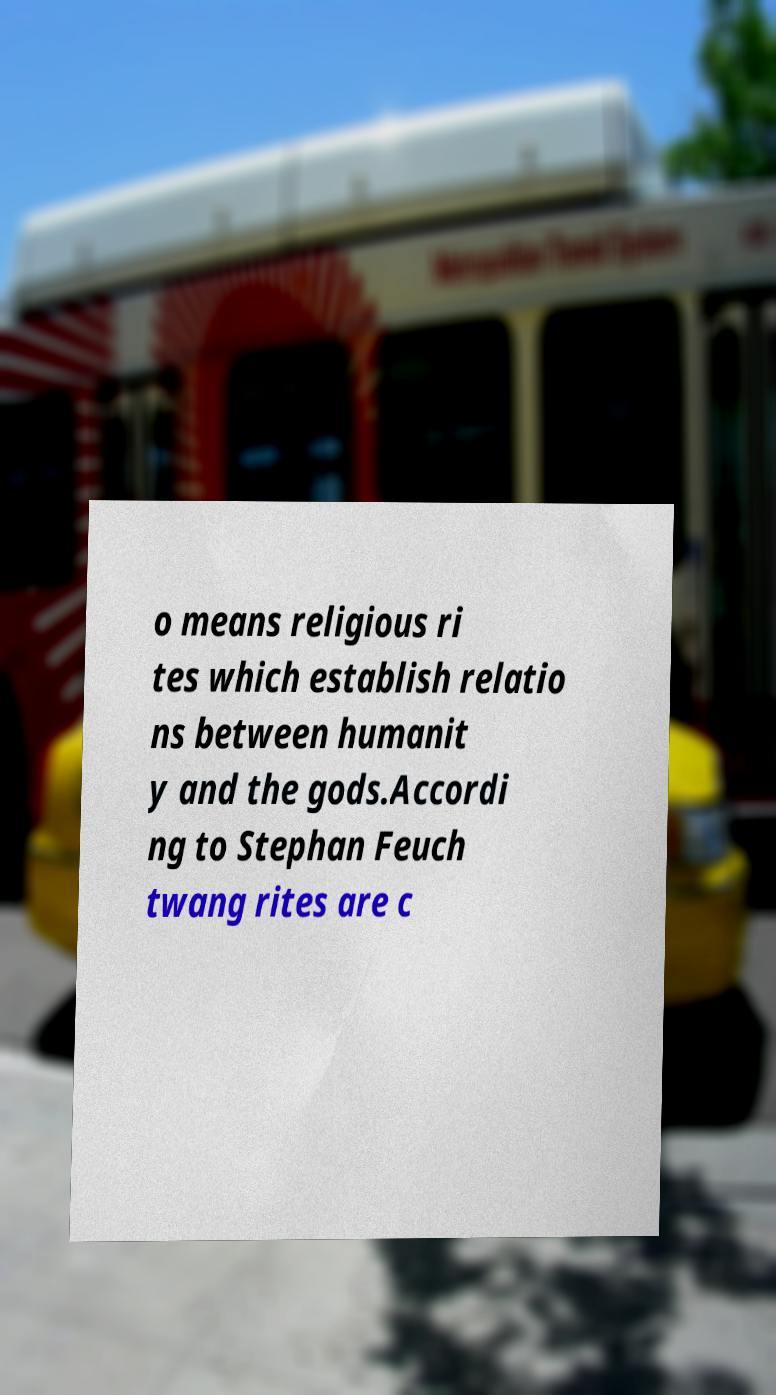Can you read and provide the text displayed in the image?This photo seems to have some interesting text. Can you extract and type it out for me? o means religious ri tes which establish relatio ns between humanit y and the gods.Accordi ng to Stephan Feuch twang rites are c 